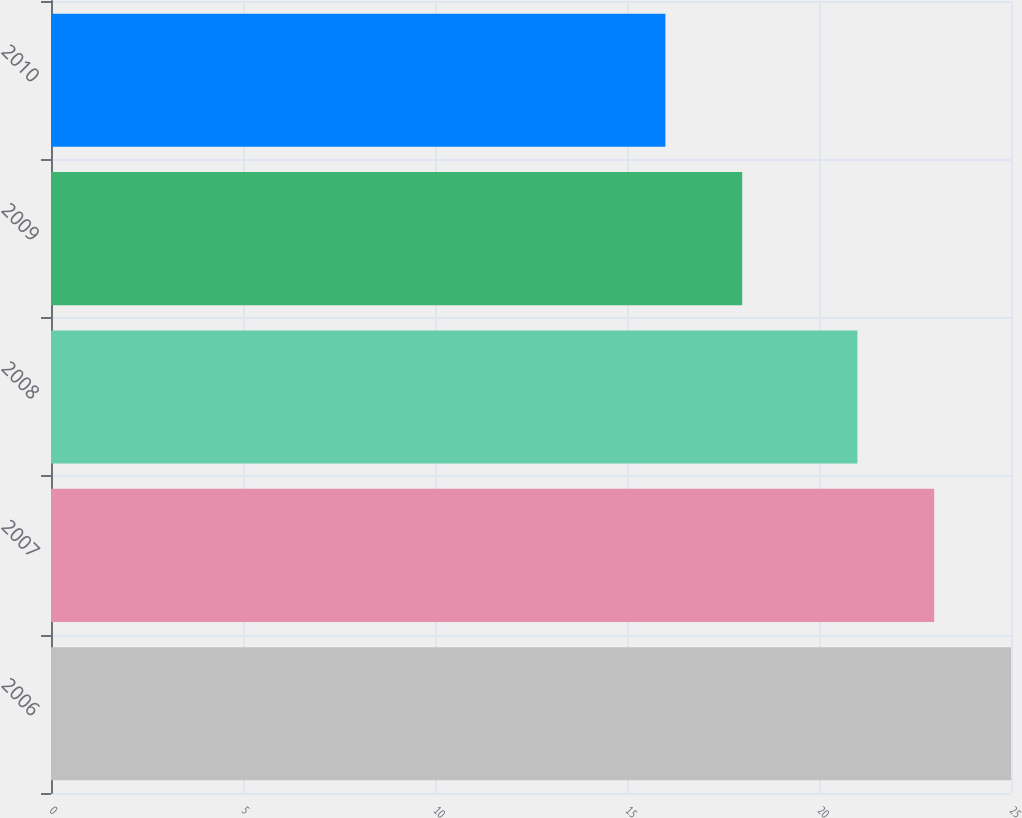Convert chart. <chart><loc_0><loc_0><loc_500><loc_500><bar_chart><fcel>2006<fcel>2007<fcel>2008<fcel>2009<fcel>2010<nl><fcel>25<fcel>23<fcel>21<fcel>18<fcel>16<nl></chart> 